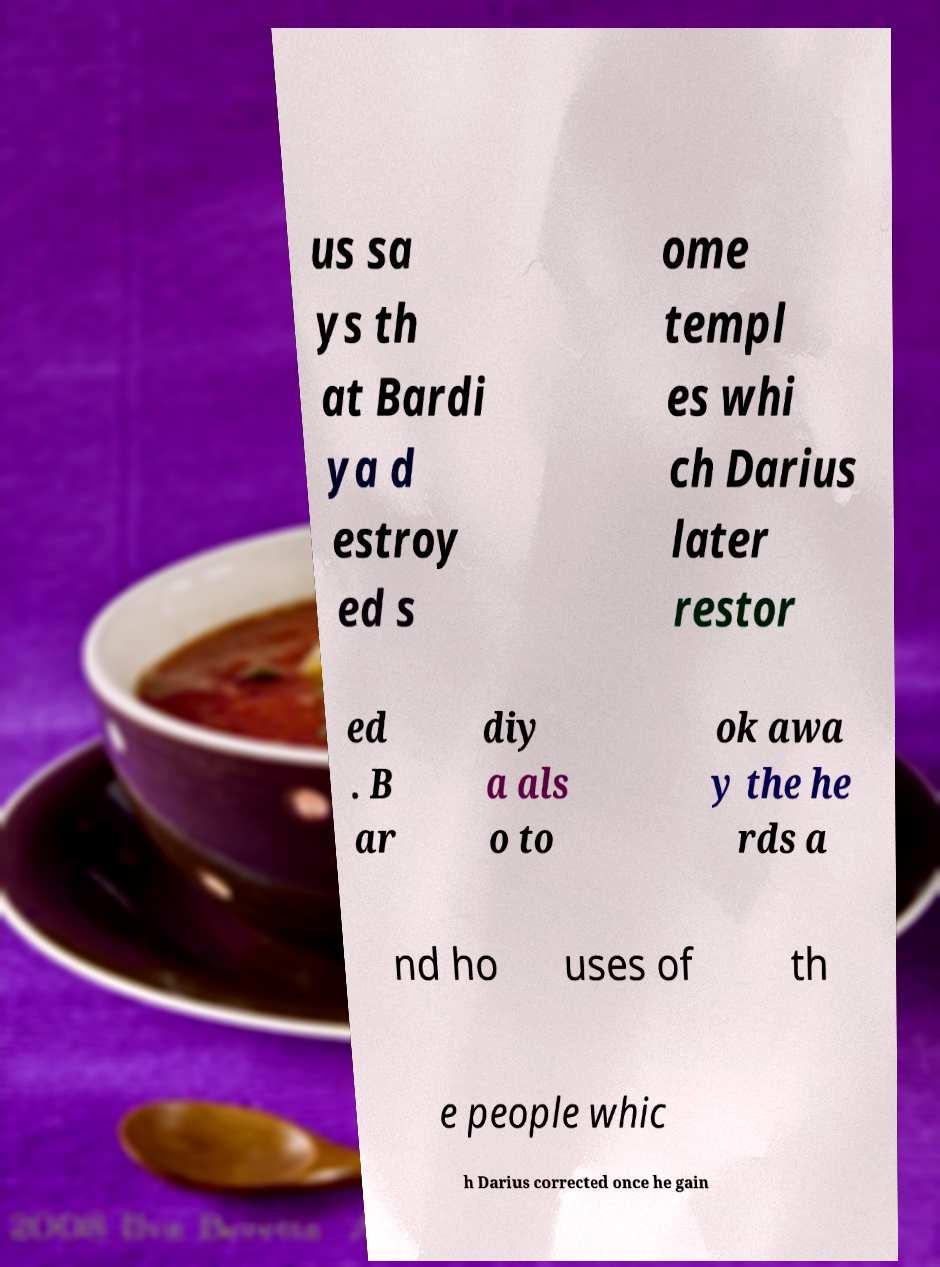Please identify and transcribe the text found in this image. us sa ys th at Bardi ya d estroy ed s ome templ es whi ch Darius later restor ed . B ar diy a als o to ok awa y the he rds a nd ho uses of th e people whic h Darius corrected once he gain 